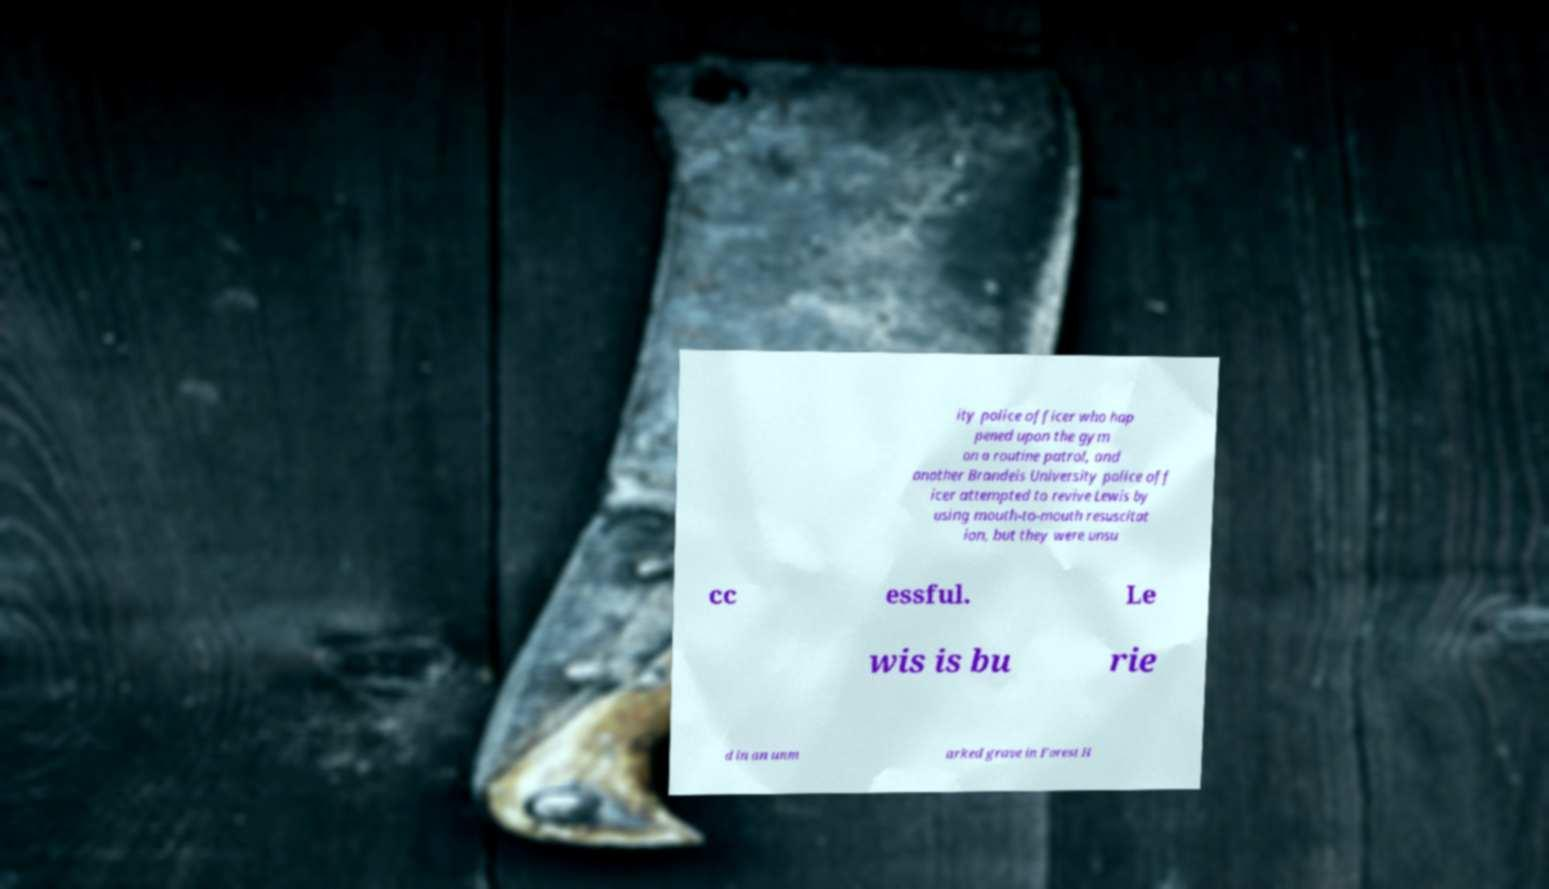For documentation purposes, I need the text within this image transcribed. Could you provide that? ity police officer who hap pened upon the gym on a routine patrol, and another Brandeis University police off icer attempted to revive Lewis by using mouth-to-mouth resuscitat ion, but they were unsu cc essful. Le wis is bu rie d in an unm arked grave in Forest H 